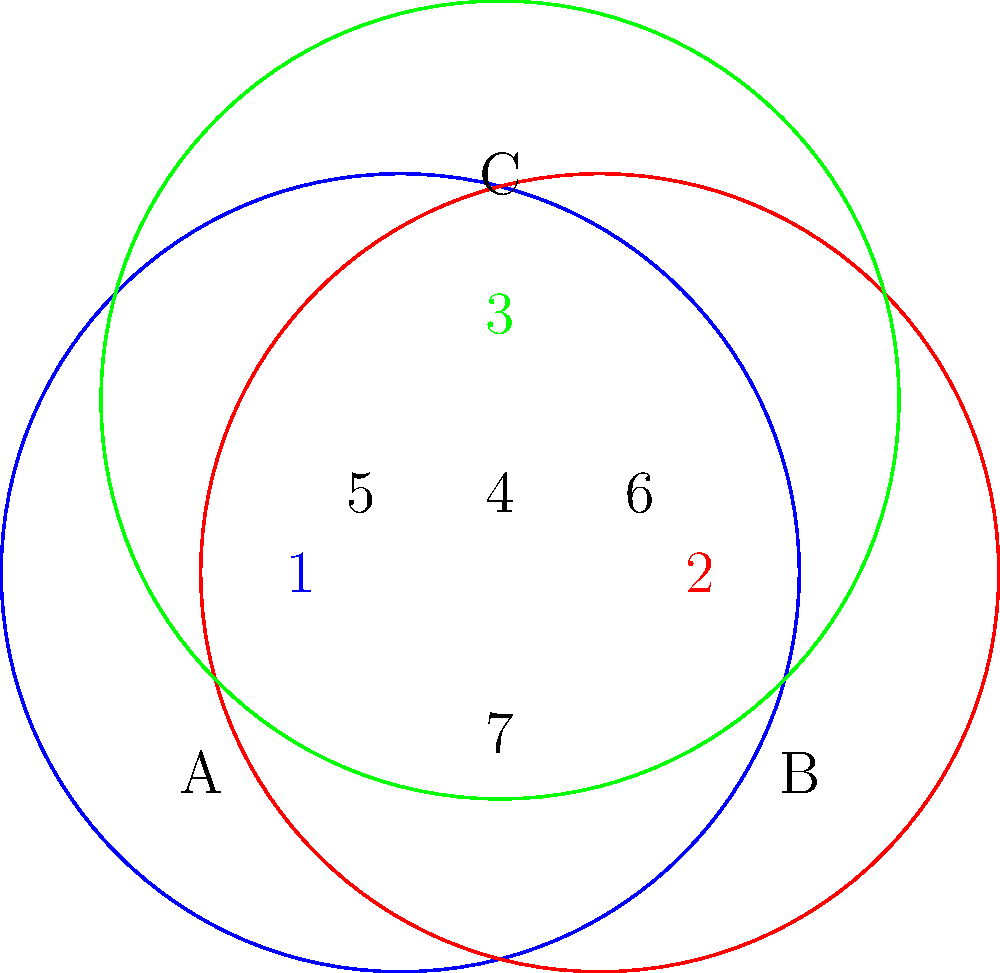In the Venn diagram above, circles A, B, and C represent consumer protection regulations in three different jurisdictions. Each numbered region represents a unique combination of overlapping regulations. As a consumer protection lawyer, which region would likely require the most complex legal analysis when reviewing an infomercial script intended for distribution across all three jurisdictions? To answer this question, we need to analyze the topology of the overlapping regulations:

1. Region 1: Only jurisdiction A's regulations apply
2. Region 2: Only jurisdiction B's regulations apply
3. Region 3: Only jurisdiction C's regulations apply
4. Region 4: Regulations from all three jurisdictions (A, B, and C) apply
5. Region 5: Regulations from jurisdictions A and C apply
6. Region 6: Regulations from jurisdictions B and C apply
7. Region 7: Regulations from jurisdictions A and B apply

The complexity of legal analysis increases with the number of overlapping jurisdictions. Therefore:

- Regions 1, 2, and 3 are the simplest, as they involve only one jurisdiction's regulations.
- Regions 5, 6, and 7 are more complex, as they involve regulations from two jurisdictions.
- Region 4 is the most complex, as it involves regulations from all three jurisdictions.

When reviewing an infomercial script for distribution across all three jurisdictions, the lawyer would need to ensure compliance with the regulations of all three jurisdictions simultaneously. This makes Region 4 the area requiring the most complex legal analysis, as it must satisfy the requirements of all three regulatory frameworks concurrently.
Answer: Region 4 